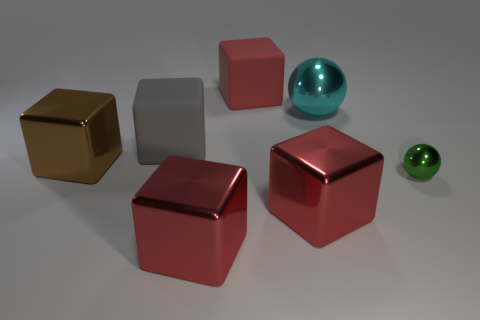How many red blocks must be subtracted to get 1 red blocks? 2 Subtract all blue balls. How many red cubes are left? 3 Subtract all gray cubes. How many cubes are left? 4 Subtract all big brown metal blocks. How many blocks are left? 4 Subtract 1 blocks. How many blocks are left? 4 Add 2 purple matte cubes. How many objects exist? 9 Subtract all blue blocks. Subtract all green cylinders. How many blocks are left? 5 Subtract all blocks. How many objects are left? 2 Subtract 0 purple balls. How many objects are left? 7 Subtract all small objects. Subtract all tiny green metallic things. How many objects are left? 5 